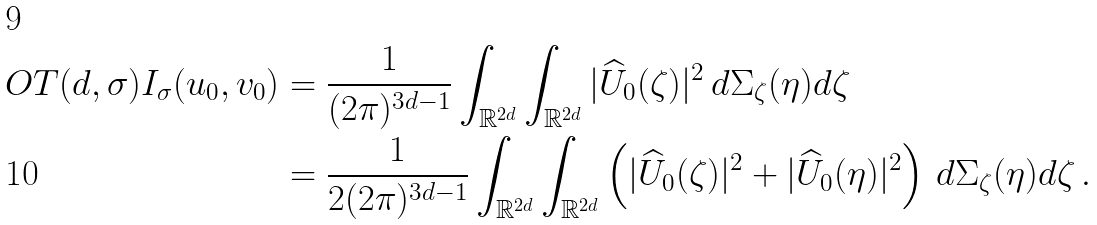<formula> <loc_0><loc_0><loc_500><loc_500>O T ( d , \sigma ) I _ { \sigma } ( u _ { 0 } , v _ { 0 } ) & = \frac { 1 } { ( 2 \pi ) ^ { 3 d - 1 } } \int _ { \mathbb { R } ^ { 2 d } } \int _ { \mathbb { R } ^ { 2 d } } | \widehat { U } _ { 0 } ( \zeta ) | ^ { 2 } \, d \Sigma _ { \zeta } ( \eta ) d \zeta \\ & = \frac { 1 } { 2 ( 2 \pi ) ^ { 3 d - 1 } } \int _ { \mathbb { R } ^ { 2 d } } \int _ { \mathbb { R } ^ { 2 d } } \left ( | \widehat { U } _ { 0 } ( \zeta ) | ^ { 2 } + | \widehat { U } _ { 0 } ( \eta ) | ^ { 2 } \right ) \, d \Sigma _ { \zeta } ( \eta ) d \zeta \, .</formula> 